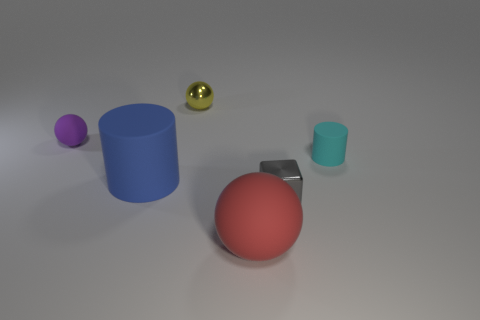Is there anything else that has the same color as the tiny rubber ball?
Offer a terse response. No. Is the big thing that is on the left side of the red thing made of the same material as the big red object?
Provide a short and direct response. Yes. Is the number of small rubber spheres behind the tiny yellow shiny ball the same as the number of large red objects that are left of the small purple rubber object?
Provide a short and direct response. Yes. What size is the cube that is on the left side of the thing to the right of the gray object?
Your answer should be compact. Small. There is a tiny thing that is on the left side of the gray metal cube and in front of the metal ball; what material is it?
Your answer should be very brief. Rubber. How many other things are there of the same size as the blue object?
Provide a short and direct response. 1. The small metal block is what color?
Your answer should be compact. Gray. Is the color of the rubber cylinder that is on the right side of the yellow metallic thing the same as the large matte object behind the gray object?
Ensure brevity in your answer.  No. The gray shiny object is what size?
Your answer should be compact. Small. There is a sphere that is behind the small purple sphere; what is its size?
Give a very brief answer. Small. 